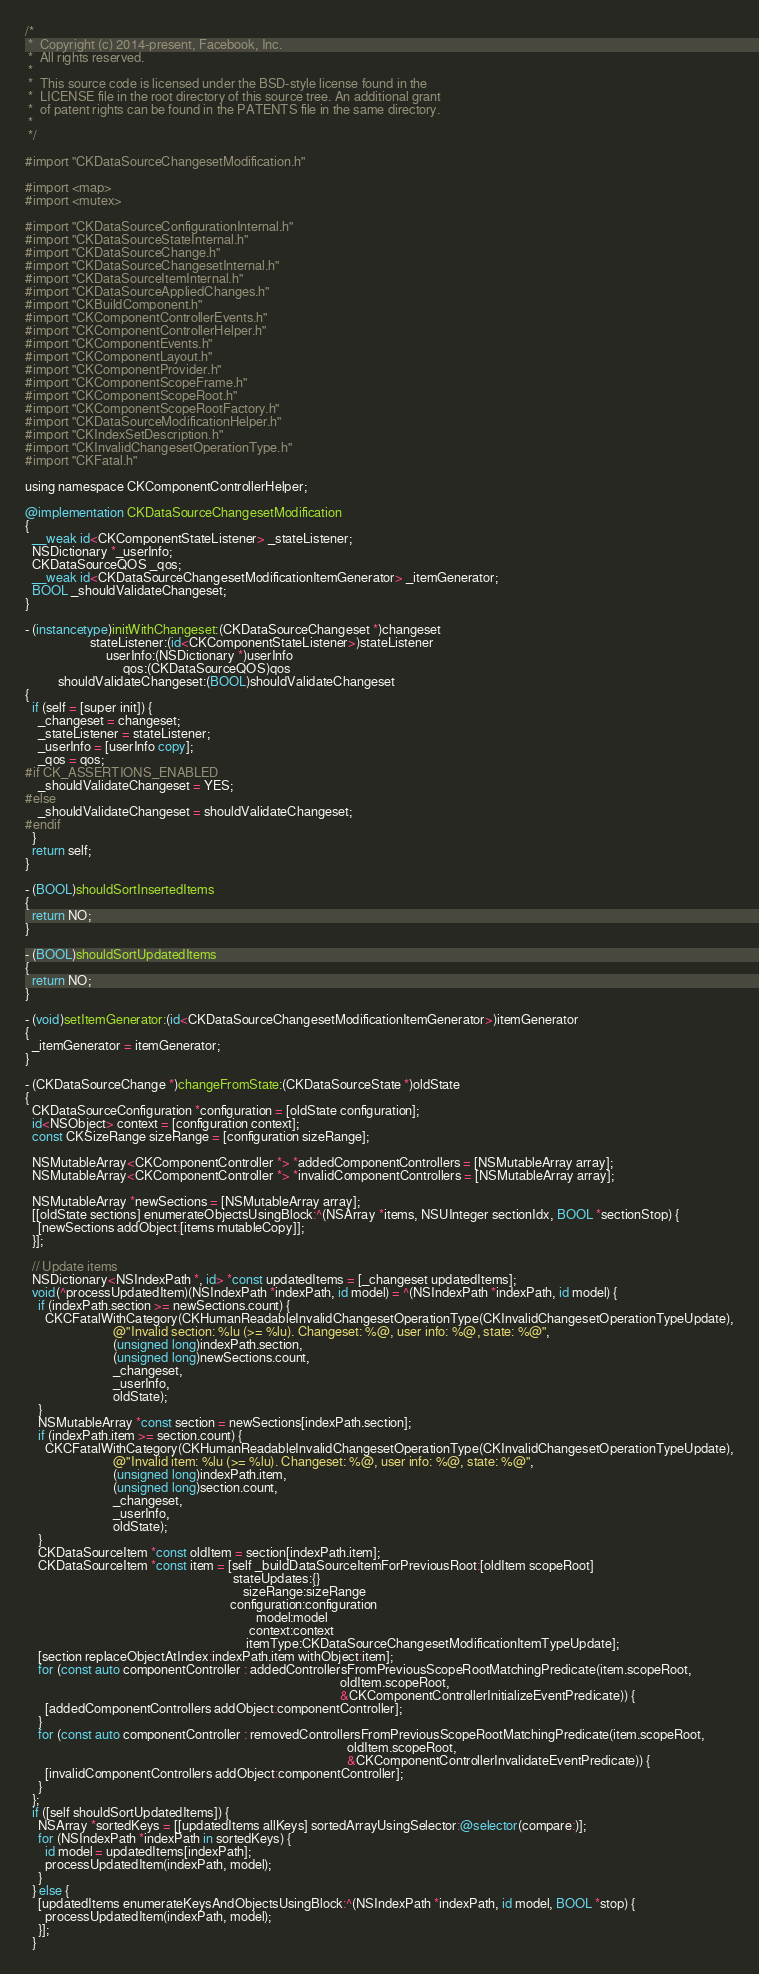Convert code to text. <code><loc_0><loc_0><loc_500><loc_500><_ObjectiveC_>/*
 *  Copyright (c) 2014-present, Facebook, Inc.
 *  All rights reserved.
 *
 *  This source code is licensed under the BSD-style license found in the
 *  LICENSE file in the root directory of this source tree. An additional grant
 *  of patent rights can be found in the PATENTS file in the same directory.
 *
 */

#import "CKDataSourceChangesetModification.h"

#import <map>
#import <mutex>

#import "CKDataSourceConfigurationInternal.h"
#import "CKDataSourceStateInternal.h"
#import "CKDataSourceChange.h"
#import "CKDataSourceChangesetInternal.h"
#import "CKDataSourceItemInternal.h"
#import "CKDataSourceAppliedChanges.h"
#import "CKBuildComponent.h"
#import "CKComponentControllerEvents.h"
#import "CKComponentControllerHelper.h"
#import "CKComponentEvents.h"
#import "CKComponentLayout.h"
#import "CKComponentProvider.h"
#import "CKComponentScopeFrame.h"
#import "CKComponentScopeRoot.h"
#import "CKComponentScopeRootFactory.h"
#import "CKDataSourceModificationHelper.h"
#import "CKIndexSetDescription.h"
#import "CKInvalidChangesetOperationType.h"
#import "CKFatal.h"

using namespace CKComponentControllerHelper;

@implementation CKDataSourceChangesetModification
{
  __weak id<CKComponentStateListener> _stateListener;
  NSDictionary *_userInfo;
  CKDataSourceQOS _qos;
  __weak id<CKDataSourceChangesetModificationItemGenerator> _itemGenerator;
  BOOL _shouldValidateChangeset;
}

- (instancetype)initWithChangeset:(CKDataSourceChangeset *)changeset
                    stateListener:(id<CKComponentStateListener>)stateListener
                         userInfo:(NSDictionary *)userInfo
                              qos:(CKDataSourceQOS)qos
          shouldValidateChangeset:(BOOL)shouldValidateChangeset
{
  if (self = [super init]) {
    _changeset = changeset;
    _stateListener = stateListener;
    _userInfo = [userInfo copy];
    _qos = qos;
#if CK_ASSERTIONS_ENABLED
    _shouldValidateChangeset = YES;
#else
    _shouldValidateChangeset = shouldValidateChangeset;
#endif
  }
  return self;
}

- (BOOL)shouldSortInsertedItems
{
  return NO;
}

- (BOOL)shouldSortUpdatedItems
{
  return NO;
}

- (void)setItemGenerator:(id<CKDataSourceChangesetModificationItemGenerator>)itemGenerator
{
  _itemGenerator = itemGenerator;
}

- (CKDataSourceChange *)changeFromState:(CKDataSourceState *)oldState
{
  CKDataSourceConfiguration *configuration = [oldState configuration];
  id<NSObject> context = [configuration context];
  const CKSizeRange sizeRange = [configuration sizeRange];

  NSMutableArray<CKComponentController *> *addedComponentControllers = [NSMutableArray array];
  NSMutableArray<CKComponentController *> *invalidComponentControllers = [NSMutableArray array];

  NSMutableArray *newSections = [NSMutableArray array];
  [[oldState sections] enumerateObjectsUsingBlock:^(NSArray *items, NSUInteger sectionIdx, BOOL *sectionStop) {
    [newSections addObject:[items mutableCopy]];
  }];

  // Update items
  NSDictionary<NSIndexPath *, id> *const updatedItems = [_changeset updatedItems];
  void(^processUpdatedItem)(NSIndexPath *indexPath, id model) = ^(NSIndexPath *indexPath, id model) {
    if (indexPath.section >= newSections.count) {
      CKCFatalWithCategory(CKHumanReadableInvalidChangesetOperationType(CKInvalidChangesetOperationTypeUpdate),
                           @"Invalid section: %lu (>= %lu). Changeset: %@, user info: %@, state: %@",
                           (unsigned long)indexPath.section,
                           (unsigned long)newSections.count,
                           _changeset,
                           _userInfo,
                           oldState);
    }
    NSMutableArray *const section = newSections[indexPath.section];
    if (indexPath.item >= section.count) {
      CKCFatalWithCategory(CKHumanReadableInvalidChangesetOperationType(CKInvalidChangesetOperationTypeUpdate),
                           @"Invalid item: %lu (>= %lu). Changeset: %@, user info: %@, state: %@",
                           (unsigned long)indexPath.item,
                           (unsigned long)section.count,
                           _changeset,
                           _userInfo,
                           oldState);
    }
    CKDataSourceItem *const oldItem = section[indexPath.item];
    CKDataSourceItem *const item = [self _buildDataSourceItemForPreviousRoot:[oldItem scopeRoot]
                                                                stateUpdates:{}
                                                                   sizeRange:sizeRange
                                                               configuration:configuration
                                                                       model:model
                                                                     context:context
                                                                    itemType:CKDataSourceChangesetModificationItemTypeUpdate];
    [section replaceObjectAtIndex:indexPath.item withObject:item];
    for (const auto componentController : addedControllersFromPreviousScopeRootMatchingPredicate(item.scopeRoot,
                                                                                                 oldItem.scopeRoot,
                                                                                                 &CKComponentControllerInitializeEventPredicate)) {
      [addedComponentControllers addObject:componentController];
    }
    for (const auto componentController : removedControllersFromPreviousScopeRootMatchingPredicate(item.scopeRoot,
                                                                                                   oldItem.scopeRoot,
                                                                                                   &CKComponentControllerInvalidateEventPredicate)) {
      [invalidComponentControllers addObject:componentController];
    }
  };
  if ([self shouldSortUpdatedItems]) {
    NSArray *sortedKeys = [[updatedItems allKeys] sortedArrayUsingSelector:@selector(compare:)];
    for (NSIndexPath *indexPath in sortedKeys) {
      id model = updatedItems[indexPath];
      processUpdatedItem(indexPath, model);
    }
  } else {
    [updatedItems enumerateKeysAndObjectsUsingBlock:^(NSIndexPath *indexPath, id model, BOOL *stop) {
      processUpdatedItem(indexPath, model);
    }];
  }
</code> 